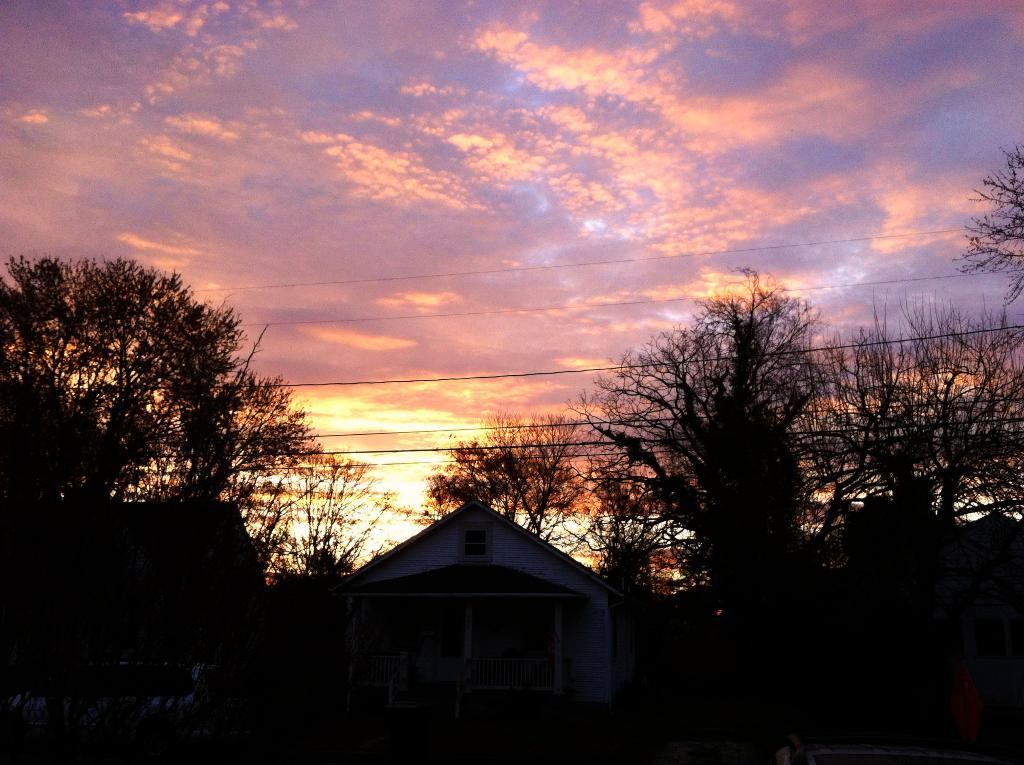What type of structure is visible in the image? There is a house in the image. What can be seen on the left side of the image? There are trees on the left side of the image. What can be seen on the right side of the image? There are trees on the right side of the image. What else is visible in the image besides the house and trees? There appear to be wires in the image. What is visible in the sky in the background of the image? There are clouds visible in the sky in the background of the image. How many chickens are attempting to burst through the walls of the house in the image? There are no chickens present in the image, nor is there any indication of an attempt to burst through the walls. 